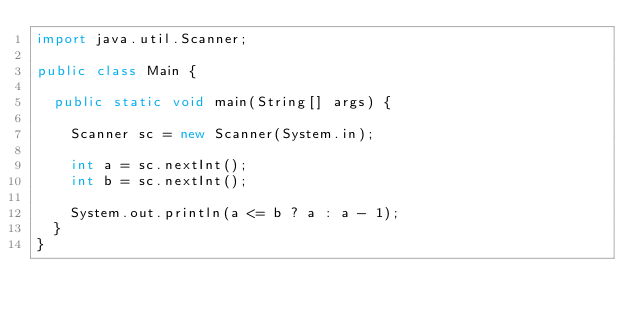<code> <loc_0><loc_0><loc_500><loc_500><_Java_>import java.util.Scanner;

public class Main {

	public static void main(String[] args) {

		Scanner sc = new Scanner(System.in);

		int a = sc.nextInt();
		int b = sc.nextInt();

		System.out.println(a <= b ? a : a - 1);
	}
}</code> 